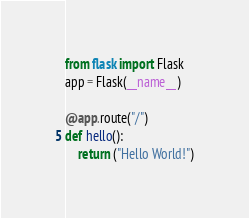Convert code to text. <code><loc_0><loc_0><loc_500><loc_500><_Python_>from flask import Flask
app = Flask(__name__)

@app.route("/")
def hello():
    return ("Hello World!")</code> 